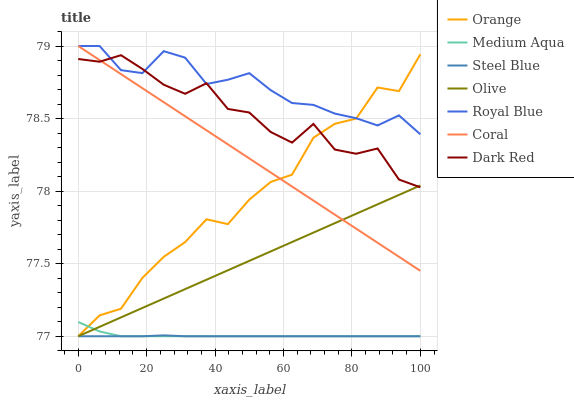Does Steel Blue have the minimum area under the curve?
Answer yes or no. Yes. Does Royal Blue have the maximum area under the curve?
Answer yes or no. Yes. Does Dark Red have the minimum area under the curve?
Answer yes or no. No. Does Dark Red have the maximum area under the curve?
Answer yes or no. No. Is Coral the smoothest?
Answer yes or no. Yes. Is Dark Red the roughest?
Answer yes or no. Yes. Is Dark Red the smoothest?
Answer yes or no. No. Is Coral the roughest?
Answer yes or no. No. Does Steel Blue have the lowest value?
Answer yes or no. Yes. Does Dark Red have the lowest value?
Answer yes or no. No. Does Coral have the highest value?
Answer yes or no. Yes. Does Dark Red have the highest value?
Answer yes or no. No. Is Steel Blue less than Dark Red?
Answer yes or no. Yes. Is Royal Blue greater than Medium Aqua?
Answer yes or no. Yes. Does Orange intersect Steel Blue?
Answer yes or no. Yes. Is Orange less than Steel Blue?
Answer yes or no. No. Is Orange greater than Steel Blue?
Answer yes or no. No. Does Steel Blue intersect Dark Red?
Answer yes or no. No. 